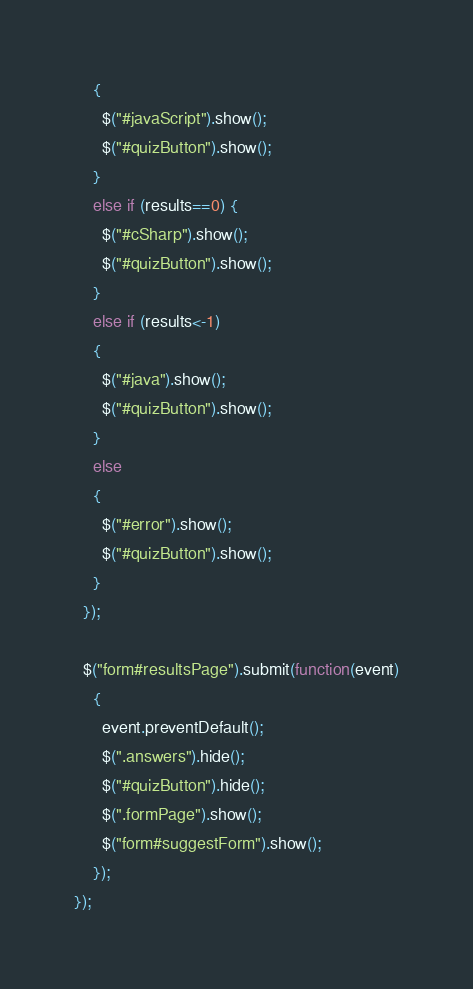Convert code to text. <code><loc_0><loc_0><loc_500><loc_500><_JavaScript_>    {
      $("#javaScript").show();
      $("#quizButton").show();
    }
    else if (results==0) {
      $("#cSharp").show();
      $("#quizButton").show();
    }
    else if (results<-1)
    {
      $("#java").show();
      $("#quizButton").show();
    }
    else
    {
      $("#error").show();
      $("#quizButton").show();
    }
  });

  $("form#resultsPage").submit(function(event)
    {
      event.preventDefault();
      $(".answers").hide();
      $("#quizButton").hide();
      $(".formPage").show();
      $("form#suggestForm").show();
    });
});
</code> 